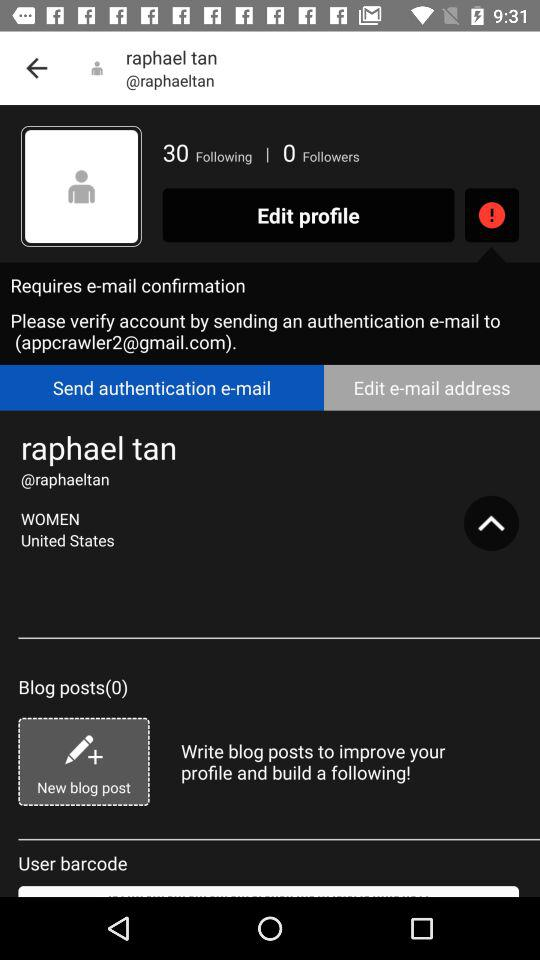What is the user name? The user name is Raphael Tan. 